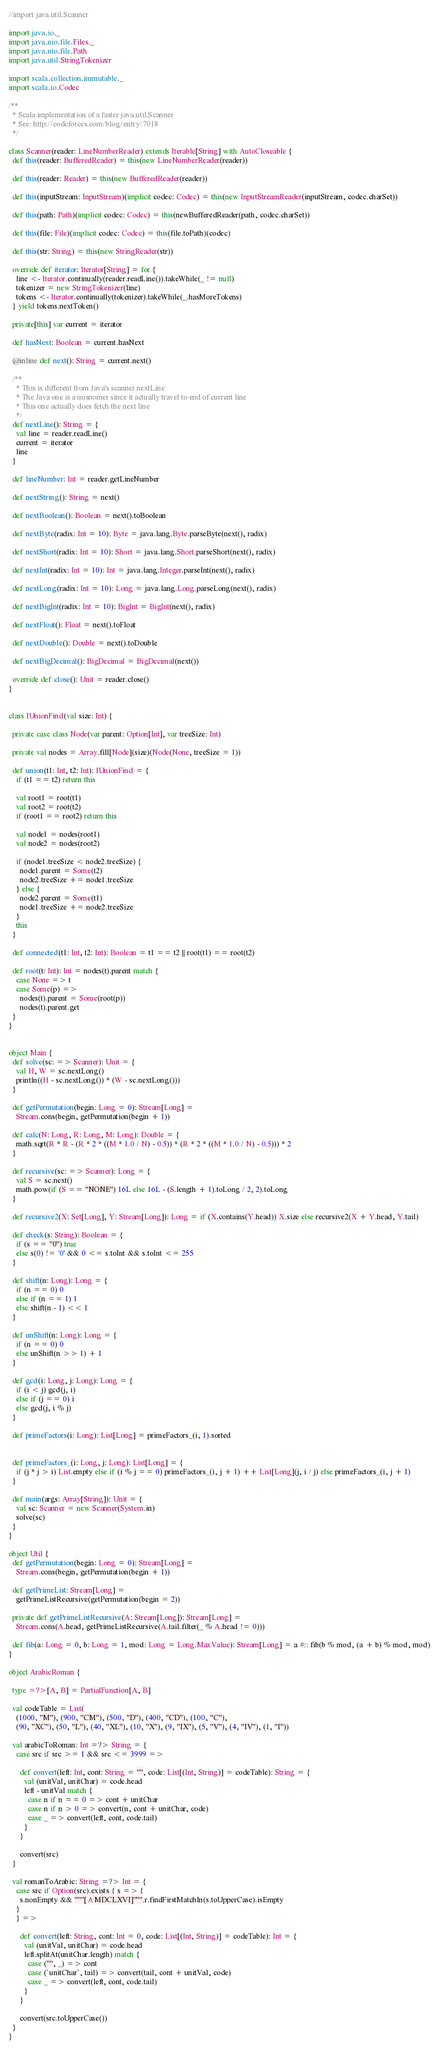<code> <loc_0><loc_0><loc_500><loc_500><_Scala_>//import java.util.Scanner

import java.io._
import java.nio.file.Files._
import java.nio.file.Path
import java.util.StringTokenizer

import scala.collection.immutable._
import scala.io.Codec

/**
  * Scala implementation of a faster java.util.Scanner
  * See: http://codeforces.com/blog/entry/7018
  */

class Scanner(reader: LineNumberReader) extends Iterable[String] with AutoCloseable {
  def this(reader: BufferedReader) = this(new LineNumberReader(reader))

  def this(reader: Reader) = this(new BufferedReader(reader))

  def this(inputStream: InputStream)(implicit codec: Codec) = this(new InputStreamReader(inputStream, codec.charSet))

  def this(path: Path)(implicit codec: Codec) = this(newBufferedReader(path, codec.charSet))

  def this(file: File)(implicit codec: Codec) = this(file.toPath)(codec)

  def this(str: String) = this(new StringReader(str))

  override def iterator: Iterator[String] = for {
    line <- Iterator.continually(reader.readLine()).takeWhile(_ != null)
    tokenizer = new StringTokenizer(line)
    tokens <- Iterator.continually(tokenizer).takeWhile(_.hasMoreTokens)
  } yield tokens.nextToken()

  private[this] var current = iterator

  def hasNext: Boolean = current.hasNext

  @inline def next(): String = current.next()

  /**
    * This is different from Java's scanner.nextLine
    * The Java one is a misnomer since it actually travel to end of current line
    * This one actually does fetch the next line
    */
  def nextLine(): String = {
    val line = reader.readLine()
    current = iterator
    line
  }

  def lineNumber: Int = reader.getLineNumber

  def nextString(): String = next()

  def nextBoolean(): Boolean = next().toBoolean

  def nextByte(radix: Int = 10): Byte = java.lang.Byte.parseByte(next(), radix)

  def nextShort(radix: Int = 10): Short = java.lang.Short.parseShort(next(), radix)

  def nextInt(radix: Int = 10): Int = java.lang.Integer.parseInt(next(), radix)

  def nextLong(radix: Int = 10): Long = java.lang.Long.parseLong(next(), radix)

  def nextBigInt(radix: Int = 10): BigInt = BigInt(next(), radix)

  def nextFloat(): Float = next().toFloat

  def nextDouble(): Double = next().toDouble

  def nextBigDecimal(): BigDecimal = BigDecimal(next())

  override def close(): Unit = reader.close()
}


class IUnionFind(val size: Int) {

  private case class Node(var parent: Option[Int], var treeSize: Int)

  private val nodes = Array.fill[Node](size)(Node(None, treeSize = 1))

  def union(t1: Int, t2: Int): IUnionFind = {
    if (t1 == t2) return this

    val root1 = root(t1)
    val root2 = root(t2)
    if (root1 == root2) return this

    val node1 = nodes(root1)
    val node2 = nodes(root2)

    if (node1.treeSize < node2.treeSize) {
      node1.parent = Some(t2)
      node2.treeSize += node1.treeSize
    } else {
      node2.parent = Some(t1)
      node1.treeSize += node2.treeSize
    }
    this
  }

  def connected(t1: Int, t2: Int): Boolean = t1 == t2 || root(t1) == root(t2)

  def root(t: Int): Int = nodes(t).parent match {
    case None => t
    case Some(p) =>
      nodes(t).parent = Some(root(p))
      nodes(t).parent.get
  }
}


object Main {
  def solve(sc: => Scanner): Unit = {
    val H, W = sc.nextLong()
    println((H - sc.nextLong()) * (W - sc.nextLong()))
  }

  def getPermutation(begin: Long = 0): Stream[Long] =
    Stream.cons(begin, getPermutation(begin + 1))

  def calc(N: Long, R: Long, M: Long): Double = {
    math.sqrt(R * R - (R * 2 * ((M * 1.0 / N) - 0.5)) * (R * 2 * ((M * 1.0 / N) - 0.5))) * 2
  }

  def recursive(sc: => Scanner): Long = {
    val S = sc.next()
    math.pow(if (S == "NONE") 16L else 16L - (S.length + 1).toLong / 2, 2).toLong
  }

  def recursive2(X: Set[Long], Y: Stream[Long]): Long = if (X.contains(Y.head)) X.size else recursive2(X + Y.head, Y.tail)

  def check(s: String): Boolean = {
    if (s == "0") true
    else s(0) != '0' && 0 <= s.toInt && s.toInt <= 255
  }

  def shift(n: Long): Long = {
    if (n == 0) 0
    else if (n == 1) 1
    else shift(n - 1) << 1
  }

  def unShift(n: Long): Long = {
    if (n == 0) 0
    else unShift(n >> 1) + 1
  }

  def gcd(i: Long, j: Long): Long = {
    if (i < j) gcd(j, i)
    else if (j == 0) i
    else gcd(j, i % j)
  }

  def primeFactors(i: Long): List[Long] = primeFactors_(i, 1).sorted


  def primeFactors_(i: Long, j: Long): List[Long] = {
    if (j * j > i) List.empty else if (i % j == 0) primeFactors_(i, j + 1) ++ List[Long](j, i / j) else primeFactors_(i, j + 1)
  }

  def main(args: Array[String]): Unit = {
    val sc: Scanner = new Scanner(System.in)
    solve(sc)
  }
}

object Util {
  def getPermutation(begin: Long = 0): Stream[Long] =
    Stream.cons(begin, getPermutation(begin + 1))

  def getPrimeList: Stream[Long] =
    getPrimeListRecursive(getPermutation(begin = 2))

  private def getPrimeListRecursive(A: Stream[Long]): Stream[Long] =
    Stream.cons(A.head, getPrimeListRecursive(A.tail.filter(_ % A.head != 0)))

  def fib(a: Long = 0, b: Long = 1, mod: Long = Long.MaxValue): Stream[Long] = a #:: fib(b % mod, (a + b) % mod, mod)
}

object ArabicRoman {

  type =?>[A, B] = PartialFunction[A, B]

  val codeTable = List(
    (1000, "M"), (900, "CM"), (500, "D"), (400, "CD"), (100, "C"),
    (90, "XC"), (50, "L"), (40, "XL"), (10, "X"), (9, "IX"), (5, "V"), (4, "IV"), (1, "I"))

  val arabicToRoman: Int =?> String = {
    case src if src >= 1 && src <= 3999 =>

      def convert(left: Int, cont: String = "", code: List[(Int, String)] = codeTable): String = {
        val (unitVal, unitChar) = code.head
        left - unitVal match {
          case n if n == 0 => cont + unitChar
          case n if n > 0 => convert(n, cont + unitChar, code)
          case _ => convert(left, cont, code.tail)
        }
      }

      convert(src)
  }

  val romanToArabic: String =?> Int = {
    case src if Option(src).exists { s => {
      s.nonEmpty && """[^MDCLXVI]""".r.findFirstMatchIn(s.toUpperCase).isEmpty
    }
    } =>

      def convert(left: String, cont: Int = 0, code: List[(Int, String)] = codeTable): Int = {
        val (unitVal, unitChar) = code.head
        left.splitAt(unitChar.length) match {
          case ("", _) => cont
          case (`unitChar`, tail) => convert(tail, cont + unitVal, code)
          case _ => convert(left, cont, code.tail)
        }
      }

      convert(src.toUpperCase())
  }
}</code> 